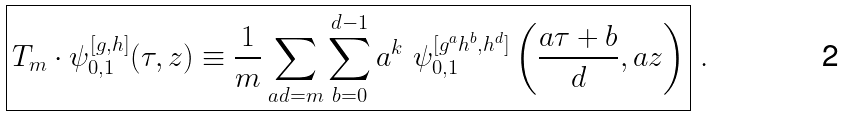<formula> <loc_0><loc_0><loc_500><loc_500>\boxed { T _ { m } \cdot \psi _ { 0 , 1 } ^ { [ g , h ] } ( \tau , z ) \equiv \frac { 1 } { m } \sum _ { a d = m } \sum _ { b = 0 } ^ { d - 1 } a ^ { k } \ \psi _ { 0 , 1 } ^ { [ g ^ { a } h ^ { b } , h ^ { d } ] } \left ( \frac { a \tau + b } { d } , a z \right ) } \ .</formula> 